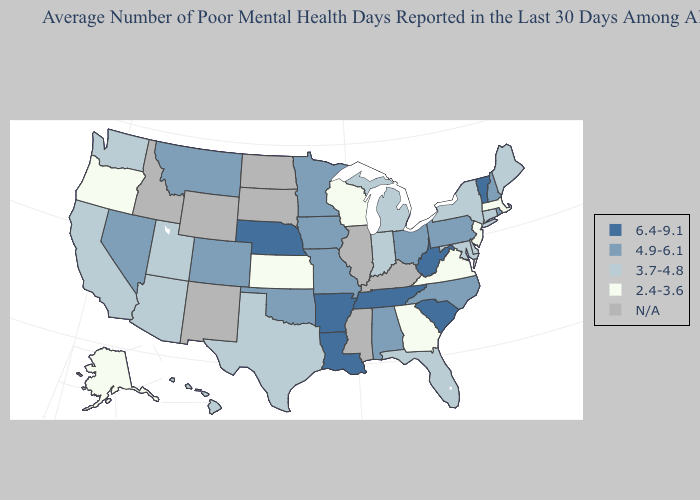Which states have the lowest value in the West?
Write a very short answer. Alaska, Oregon. Among the states that border Louisiana , which have the highest value?
Keep it brief. Arkansas. What is the highest value in the USA?
Answer briefly. 6.4-9.1. What is the highest value in the Northeast ?
Keep it brief. 6.4-9.1. Which states have the highest value in the USA?
Quick response, please. Arkansas, Louisiana, Nebraska, South Carolina, Tennessee, Vermont, West Virginia. Among the states that border Wisconsin , does Michigan have the highest value?
Concise answer only. No. Name the states that have a value in the range 3.7-4.8?
Write a very short answer. Arizona, California, Connecticut, Delaware, Florida, Hawaii, Indiana, Maine, Maryland, Michigan, New York, Texas, Utah, Washington. What is the value of Vermont?
Concise answer only. 6.4-9.1. Name the states that have a value in the range 6.4-9.1?
Be succinct. Arkansas, Louisiana, Nebraska, South Carolina, Tennessee, Vermont, West Virginia. What is the value of Rhode Island?
Concise answer only. 4.9-6.1. Name the states that have a value in the range 3.7-4.8?
Keep it brief. Arizona, California, Connecticut, Delaware, Florida, Hawaii, Indiana, Maine, Maryland, Michigan, New York, Texas, Utah, Washington. Does the map have missing data?
Give a very brief answer. Yes. Does Oklahoma have the highest value in the South?
Write a very short answer. No. 